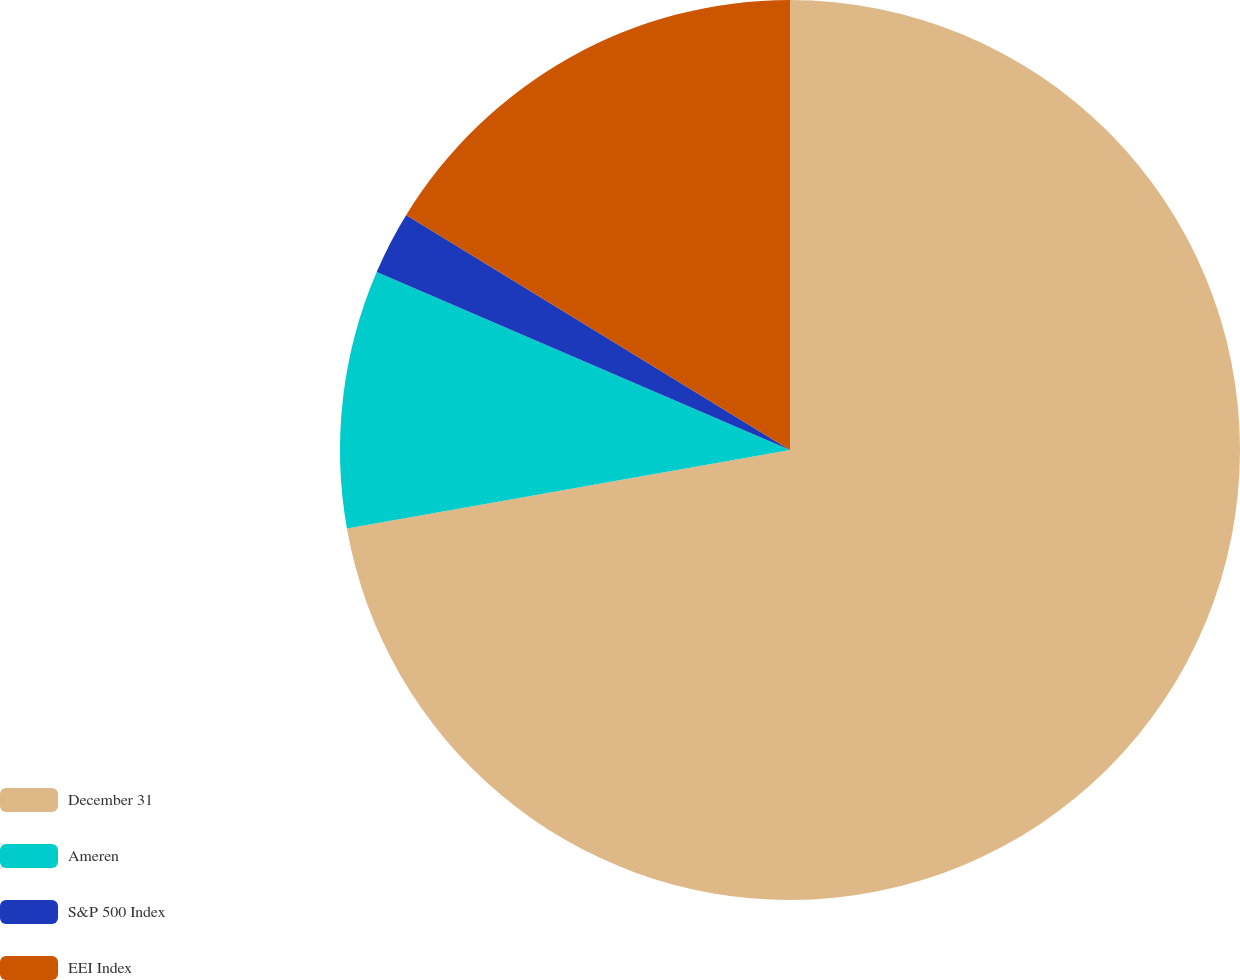<chart> <loc_0><loc_0><loc_500><loc_500><pie_chart><fcel>December 31<fcel>Ameren<fcel>S&P 500 Index<fcel>EEI Index<nl><fcel>72.22%<fcel>9.26%<fcel>2.27%<fcel>16.26%<nl></chart> 